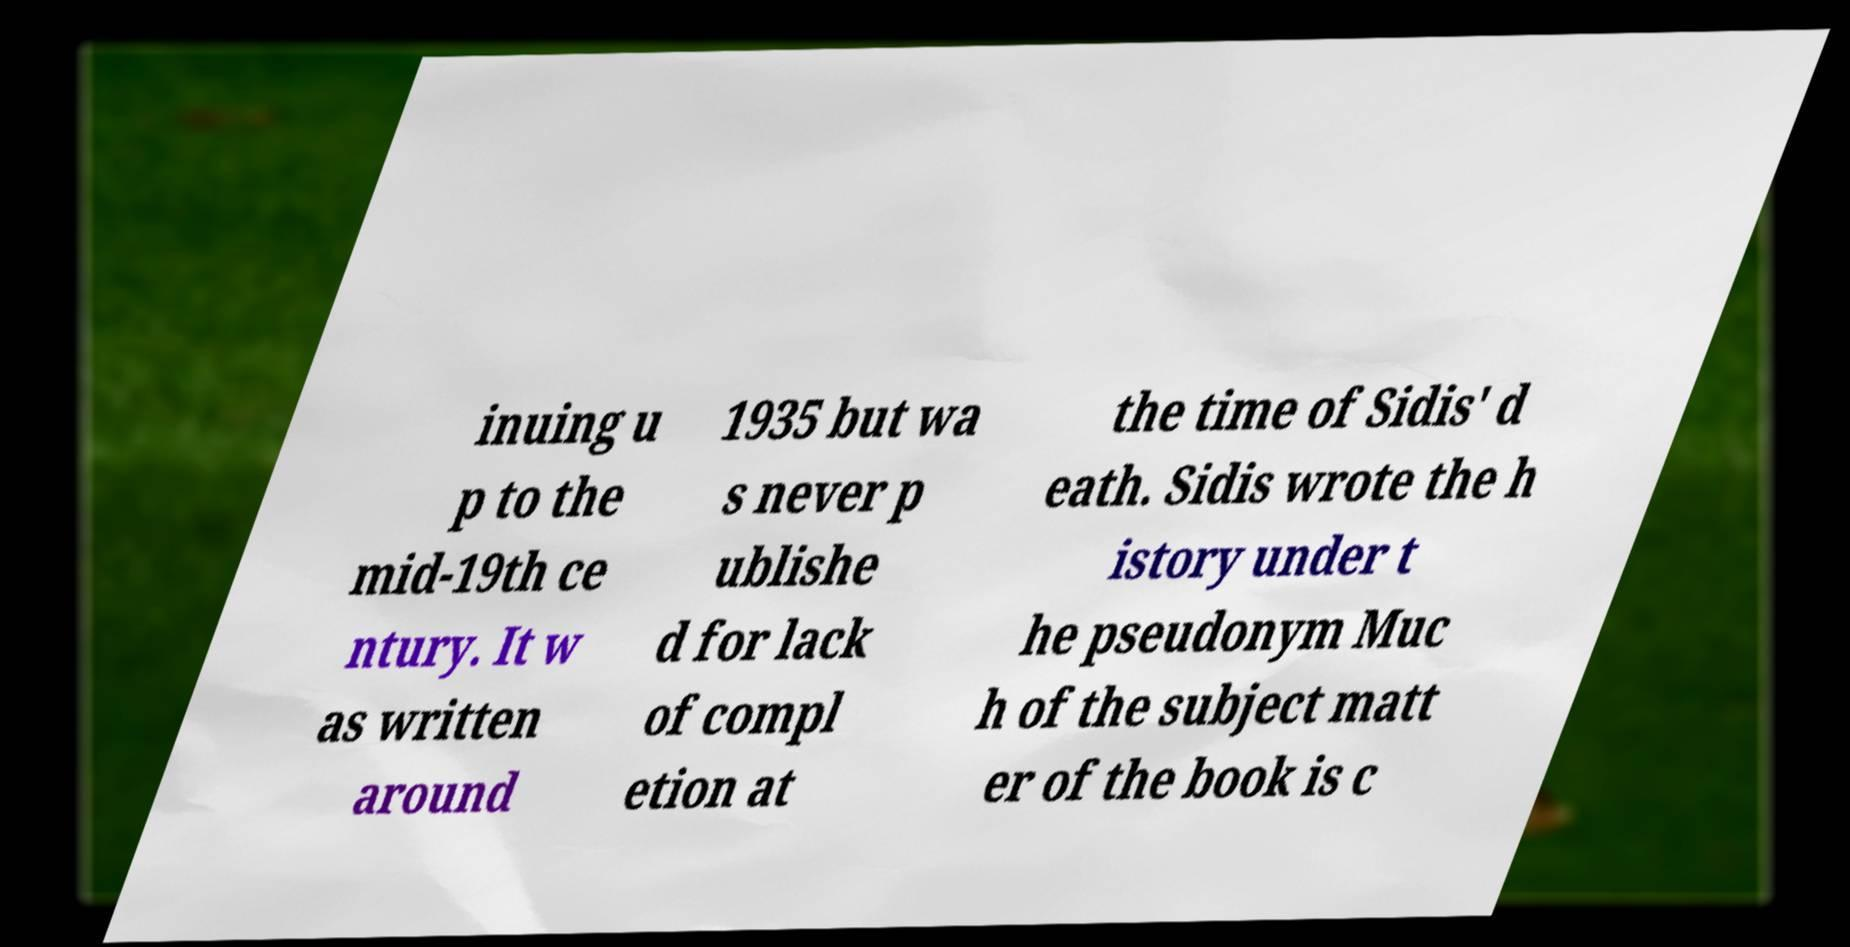Can you read and provide the text displayed in the image?This photo seems to have some interesting text. Can you extract and type it out for me? inuing u p to the mid-19th ce ntury. It w as written around 1935 but wa s never p ublishe d for lack of compl etion at the time of Sidis' d eath. Sidis wrote the h istory under t he pseudonym Muc h of the subject matt er of the book is c 